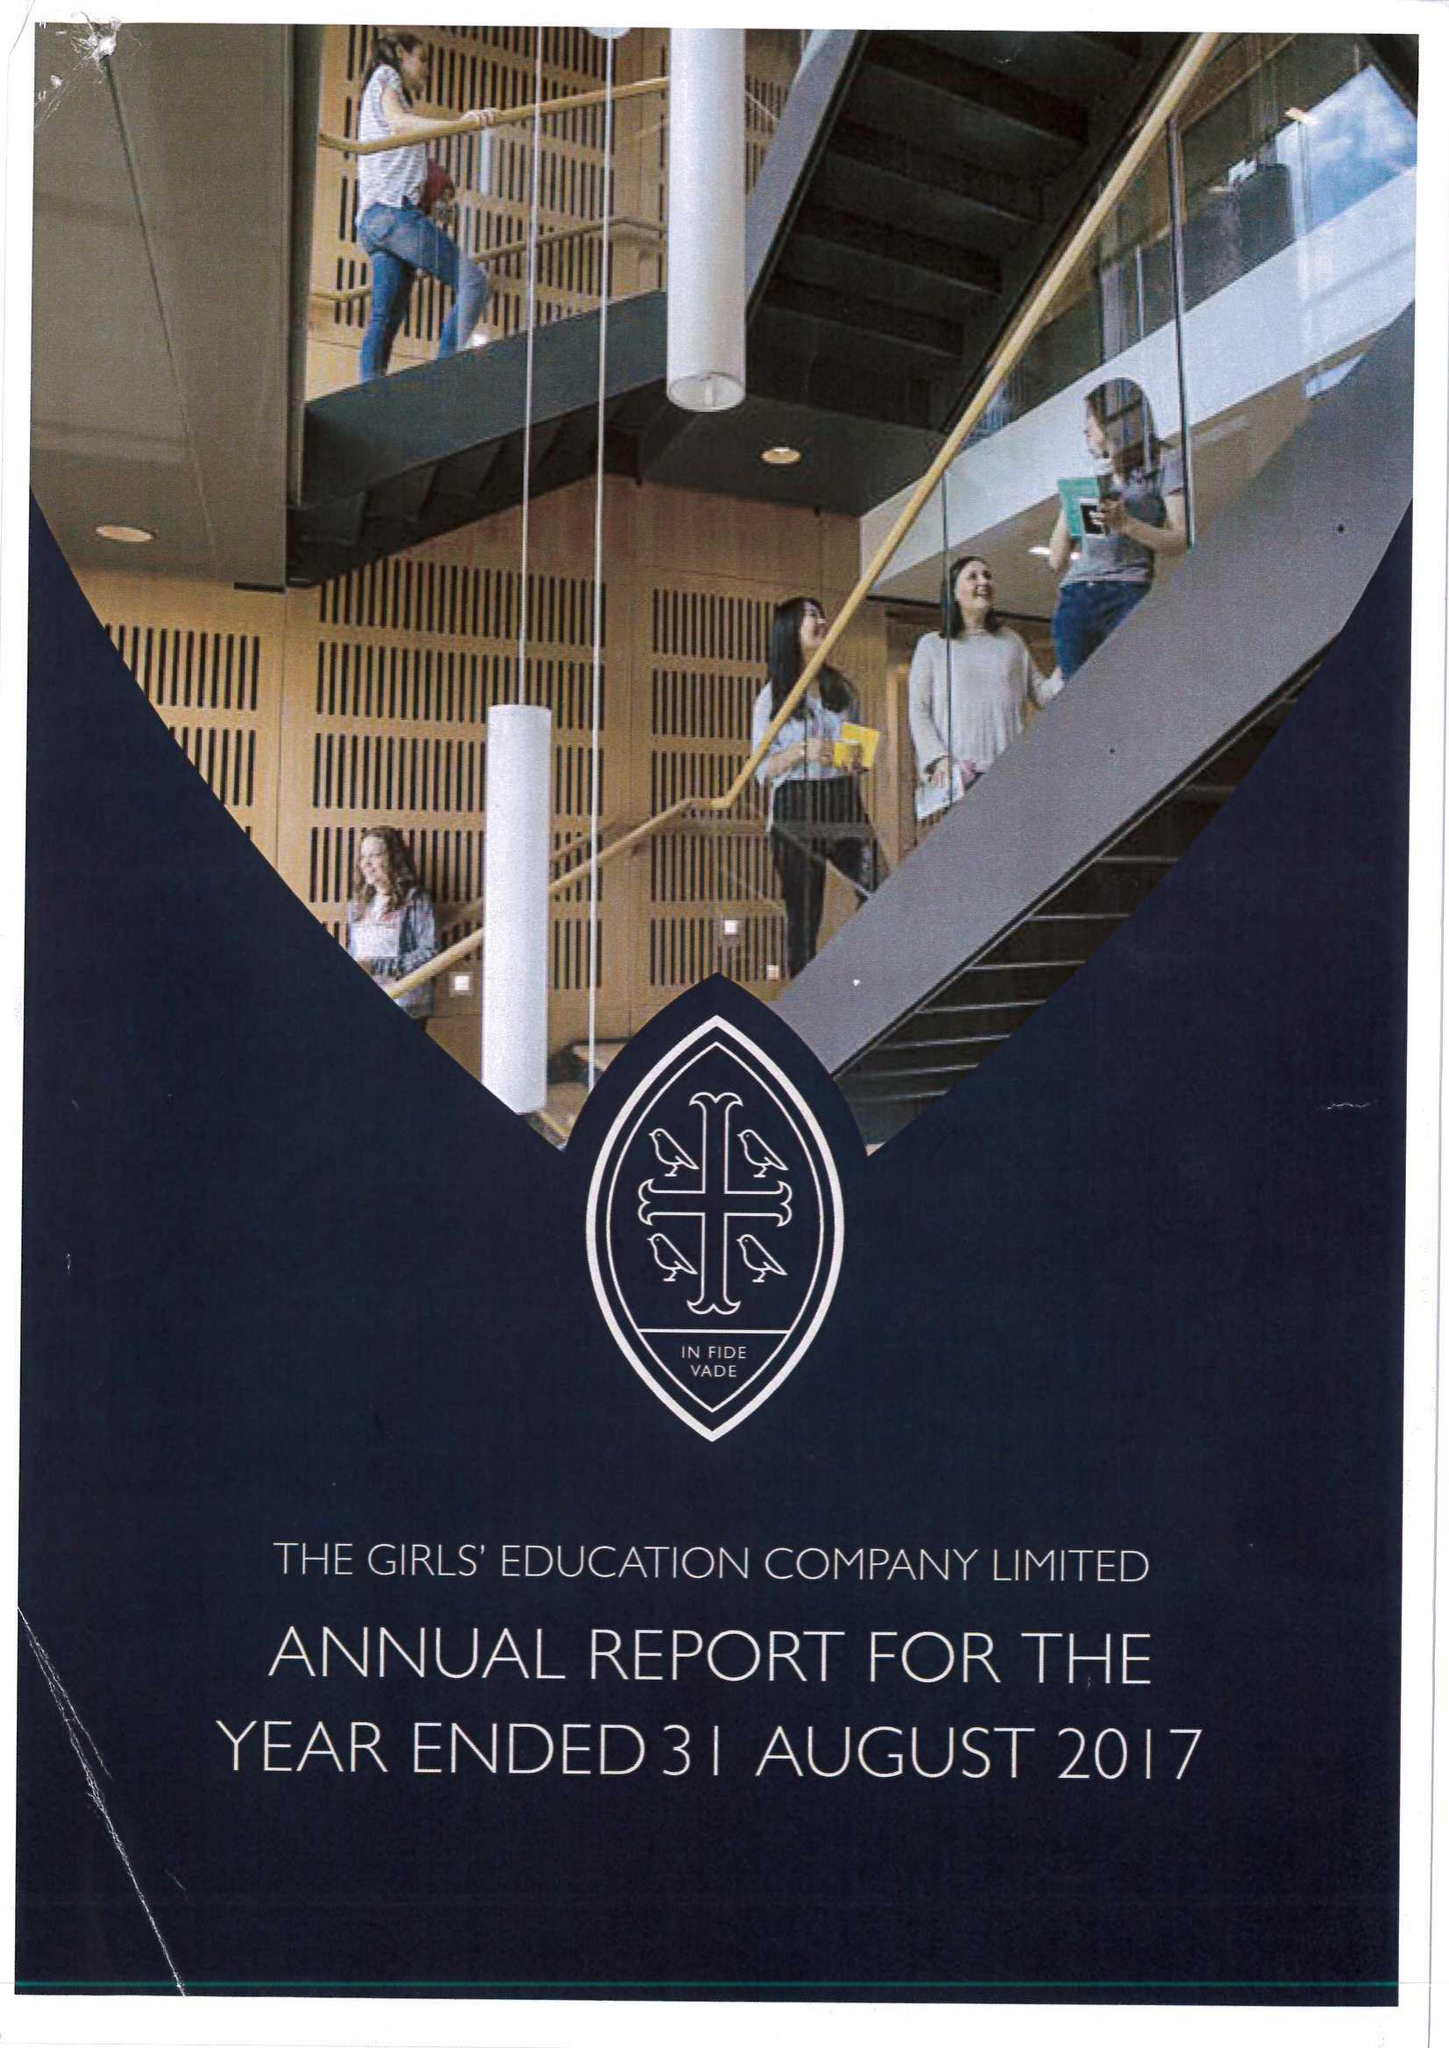What is the value for the income_annually_in_british_pounds?
Answer the question using a single word or phrase. 23900000.00 